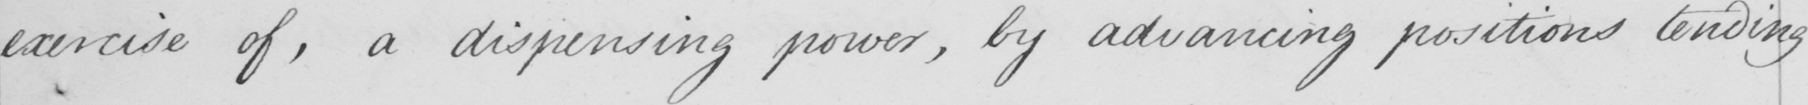Transcribe the text shown in this historical manuscript line. exercise of , a dispensing power , by advancing positions tending 